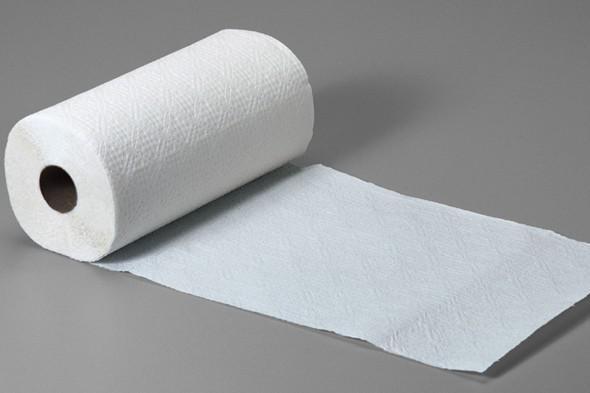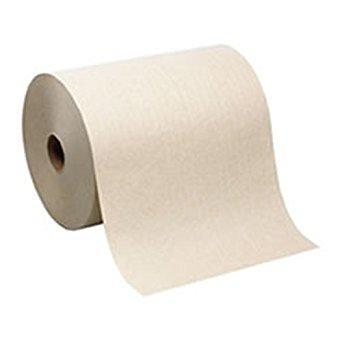The first image is the image on the left, the second image is the image on the right. Analyze the images presented: Is the assertion "One roll of tan and one roll of white paper towels are laying horizontally." valid? Answer yes or no. Yes. 